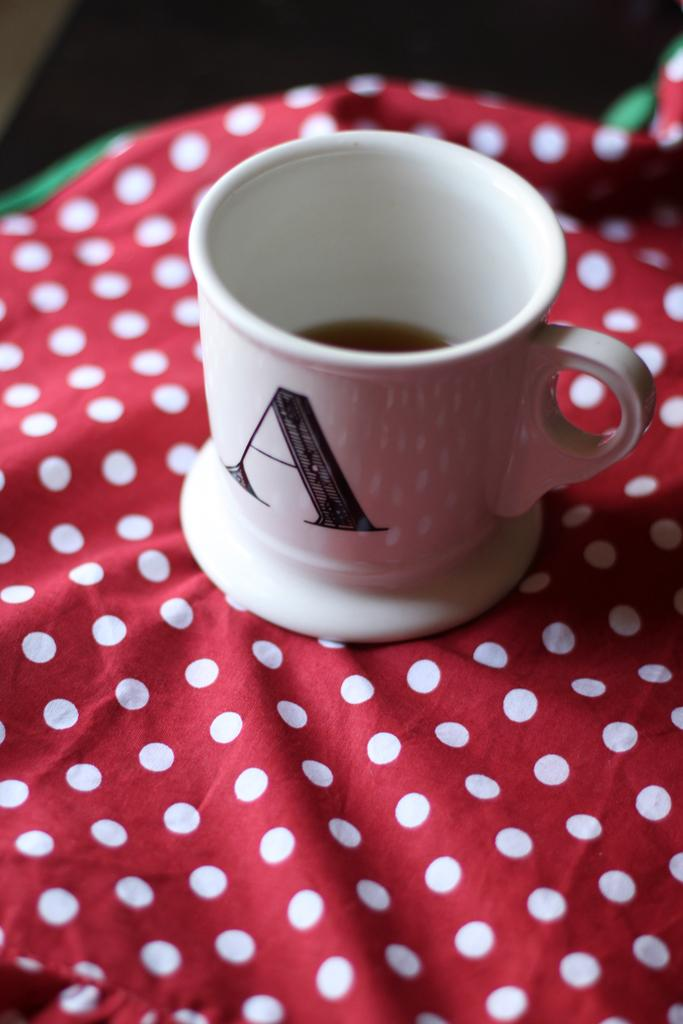Provide a one-sentence caption for the provided image. A coffee mug monogrammed with the letter A is sitting on a polka dot cloth. 